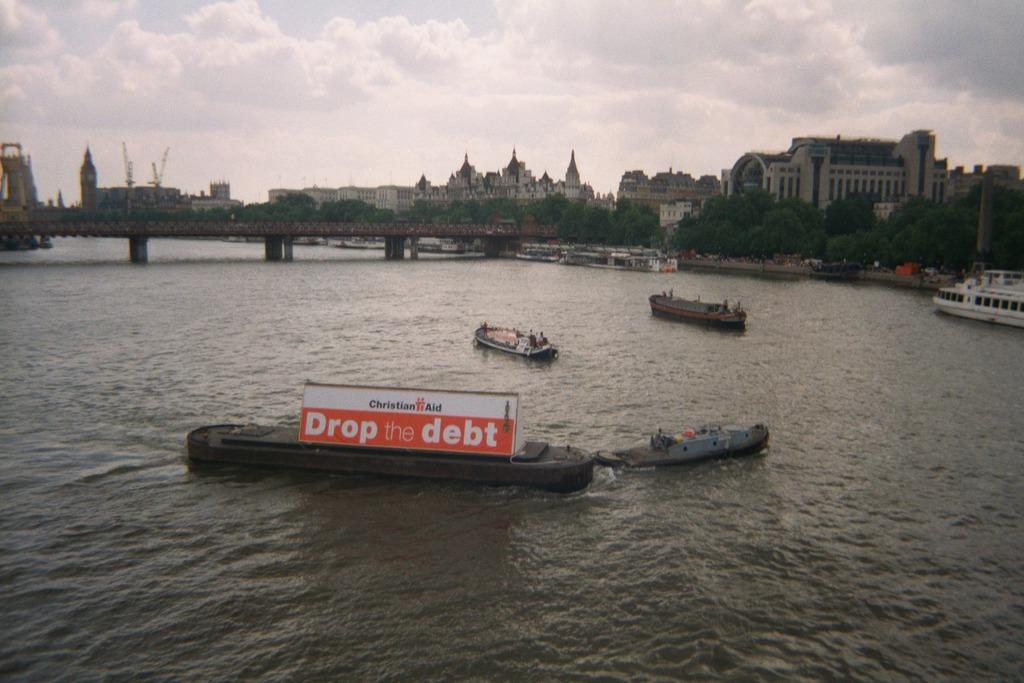What type of structures can be seen in the image? There are buildings in the image. What natural elements are present in the image? There are trees in the image. What man-made structure connects two areas in the image? There is a bridge in the image. What type of vehicles are present in the water in the image? There are boats and ships in the image. What is the primary substance visible in the image? Water is visible in the image. What is the color of the sky in the image? The sky is blue and white in color. Can you tell me how many ducks are swimming under the bridge in the image? There are no ducks present in the image; it features buildings, trees, a bridge, boats, ships, water, and a blue and white sky. What type of veil is covering the buildings in the image? There is no veil present in the image; the buildings are visible without any covering. 